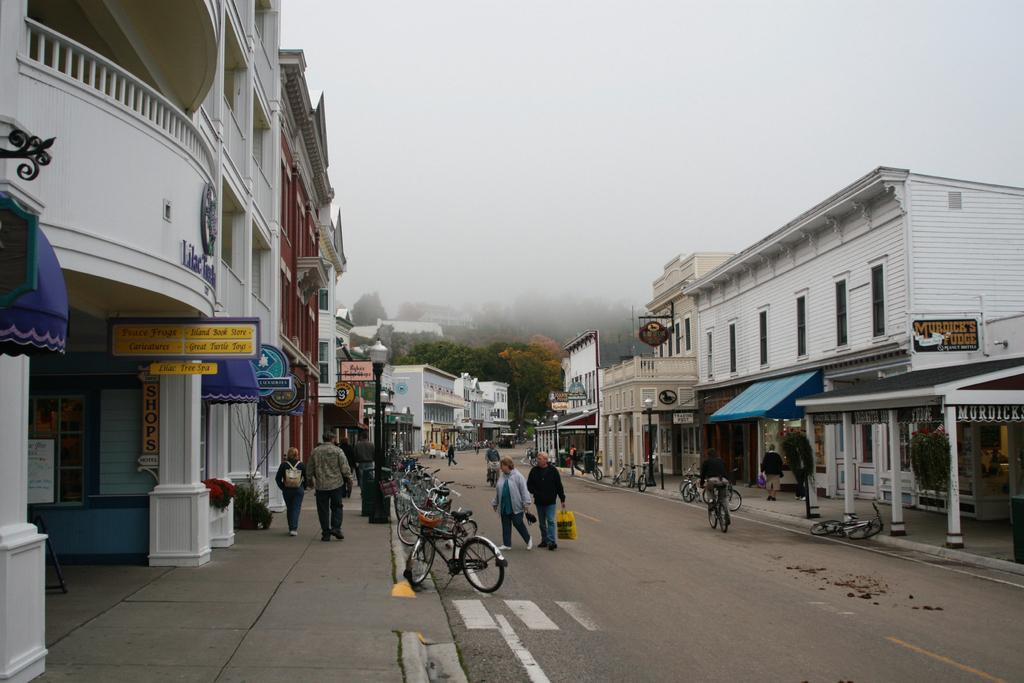What can be seen in the image? There are people, bicycles, bins, poles, lights, plants, boards, pillars, buildings, trees, and the sky visible in the image. What are the people doing in the image? The activity of the people cannot be determined from the provided facts. What type of structures are present in the image? The structures present in the image include poles, boards, pillars, and buildings. What type of vegetation is visible in the image? Plants and trees are visible in the image. What is visible in the background of the image? The sky is visible in the background of the image. How many feet are visible in the image? There is no mention of feet in the provided facts, so it cannot be determined how many feet are visible in the image. What type of line is being drawn in the image? There is no line present in the image, so it cannot be determined what type of line is being drawn. 